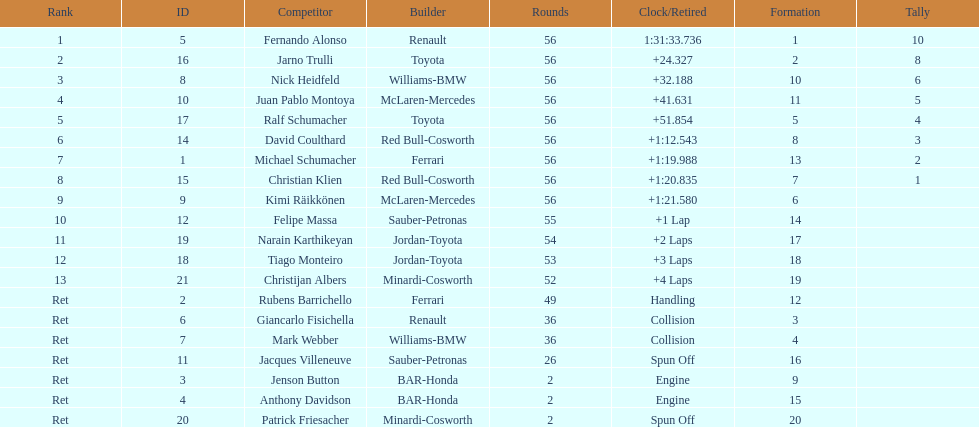How long did it take for heidfeld to finish? 1:31:65.924. 